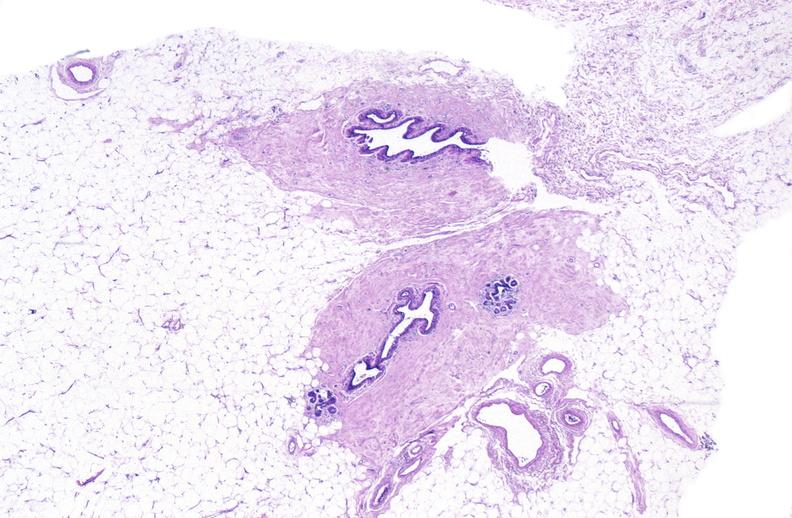does this image show normal breast?
Answer the question using a single word or phrase. Yes 